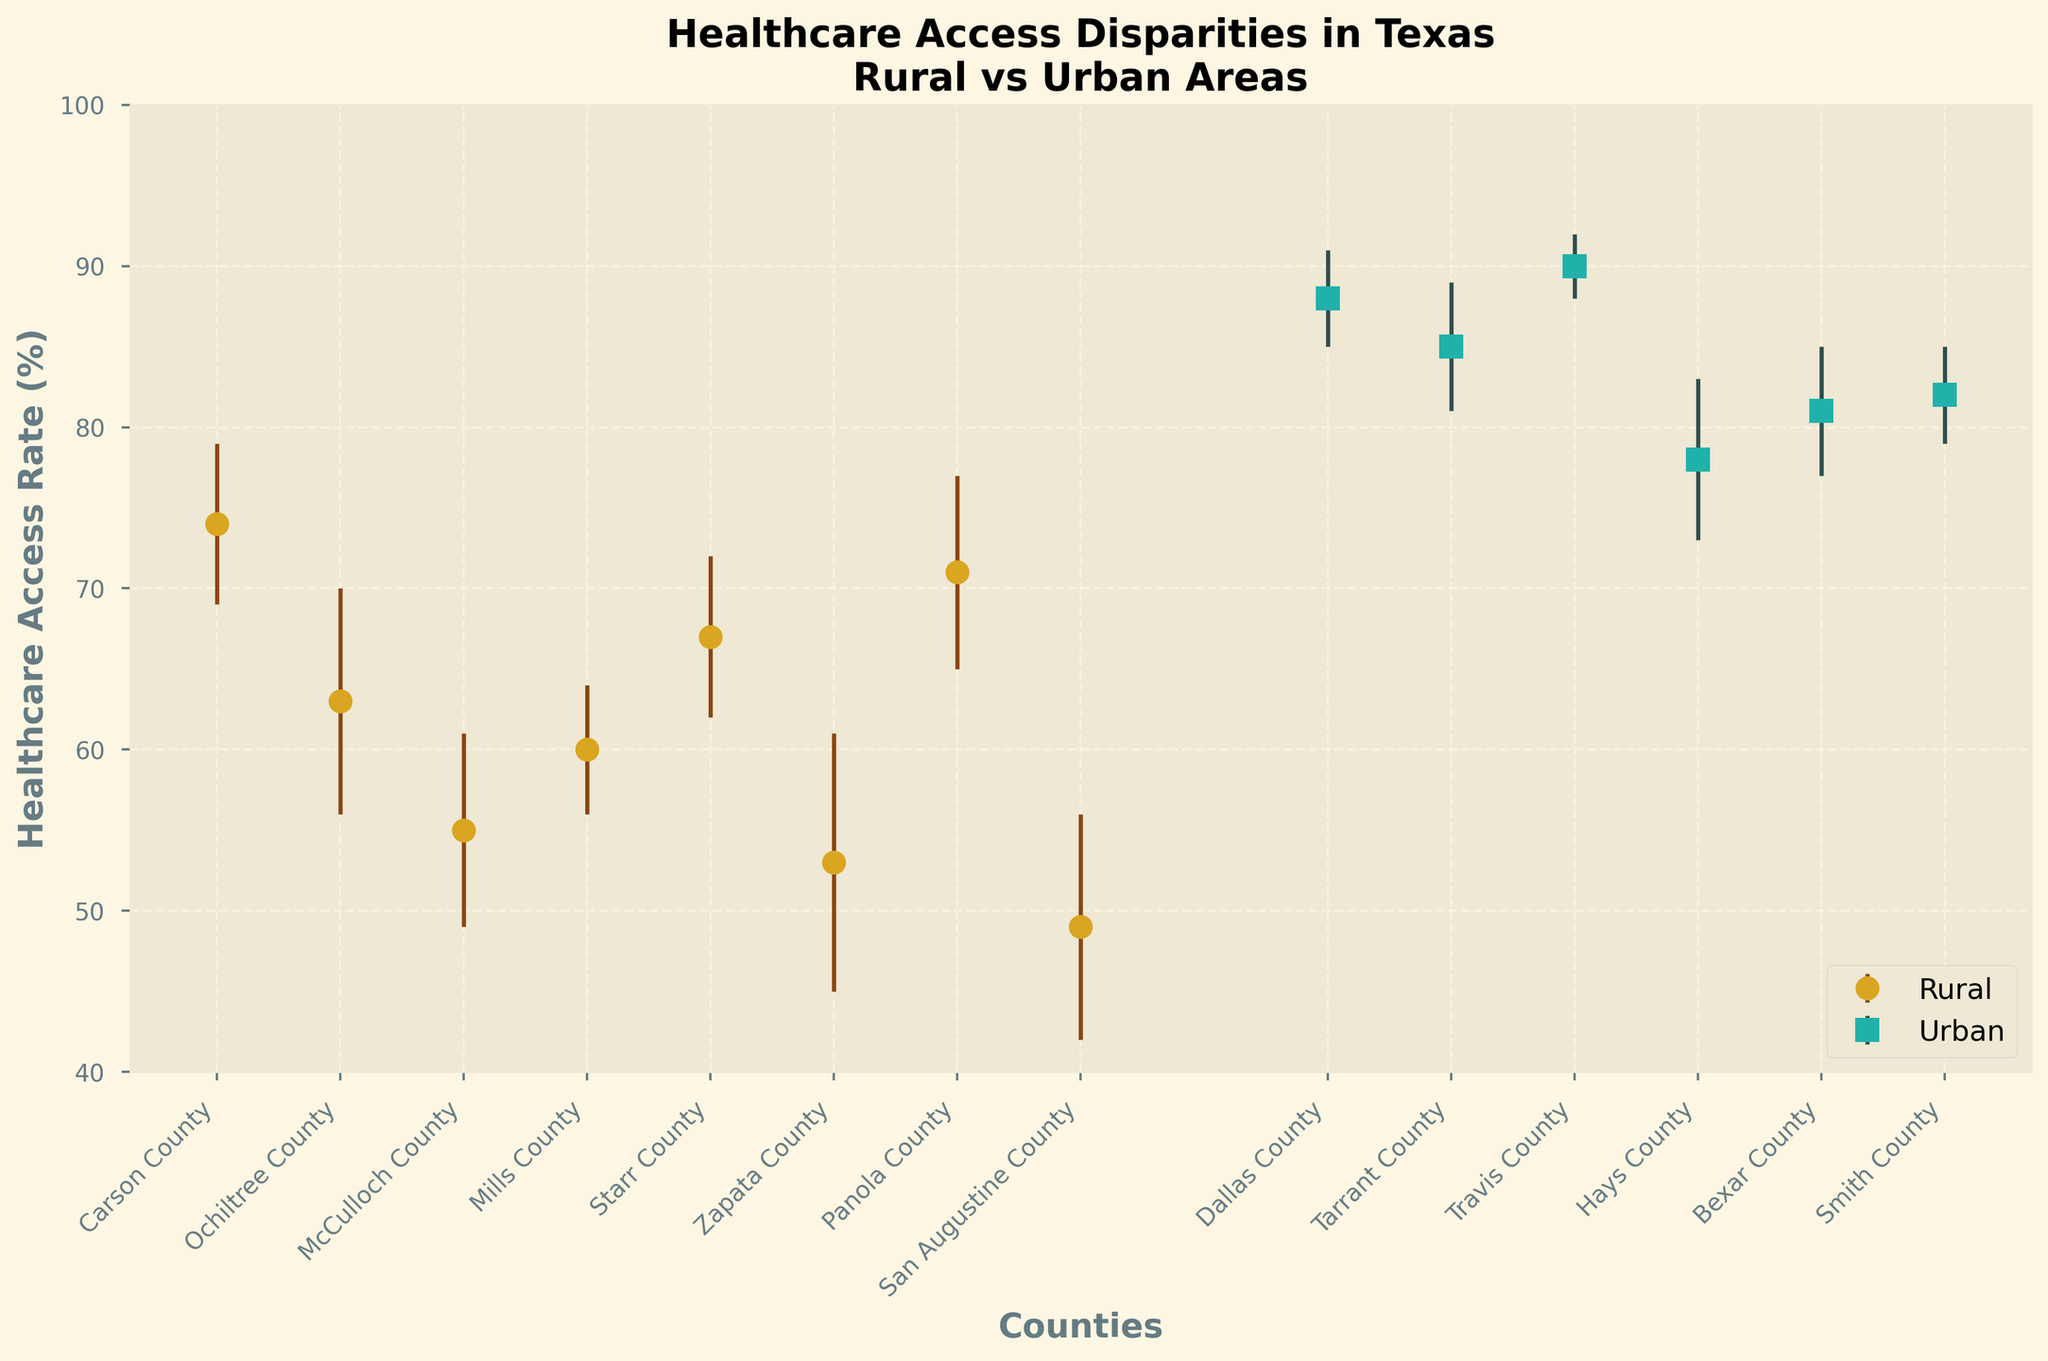What is the title of the figure? The title is located at the top of the figure and provides a summary of what the figure represents. The title in the figure reads, "Healthcare Access Disparities in Texas\nRural vs Urban Areas."
Answer: Healthcare Access Disparities in Texas\nRural vs Urban Areas How many counties are listed in the Urban areas? The data points for urban counties are marked with squares and there are six distinct square markers in the figure.
Answer: 6 What is the healthcare access rate for Starr County? The dot representing Starr County is located within the rural area section. The dot is at the level corresponding to 67%.
Answer: 67% Which Urban county has the highest healthcare access rate? Look at the urban markers, and identify which one is the highest on the y-axis. Travis County has the highest marker, corresponding to 90%.
Answer: Travis County What is the color used for Rural area markers? Rural area markers are represented by the circular dots, which are colored in a gold hue.
Answer: Gold How much higher is the healthcare access rate in Dallas County compared to McCulloch County? Identify the access rates for both counties. Dallas County has an access rate of 88%, while McCulloch County has an access rate of 55%. Subtract to find the difference: 88% - 55% = 33%.
Answer: 33% What is the error margin for Zapata County? Observe the vertical line (error bar) around the dot representing Zapata County. The error margin indicated for Zapata County is 8%.
Answer: 8% Which has a lower minimum healthcare access rate, Rural or Urban areas? Compare the lowest points for rural and urban areas. The lowest rate for rural areas is for San Augustine County at 49%, and for urban areas, it's Hays County at 78%. 49% is lower than 78%.
Answer: Rural areas What is the average healthcare access rate for the Central Texas urban counties? Identify the access rates for Central Texas urban counties (Travis County and Hays County) which are 90% and 78% respectively. Calculate the average: (90 + 78) / 2 = 84%.
Answer: 84% How many counties have a healthcare access rate below 60%? Find all the points marked for counties with rates below 60%. These counties are McCulloch County (55%), Zapata County (53%), and San Augustine County (49%), resulting in three counts.
Answer: 3 